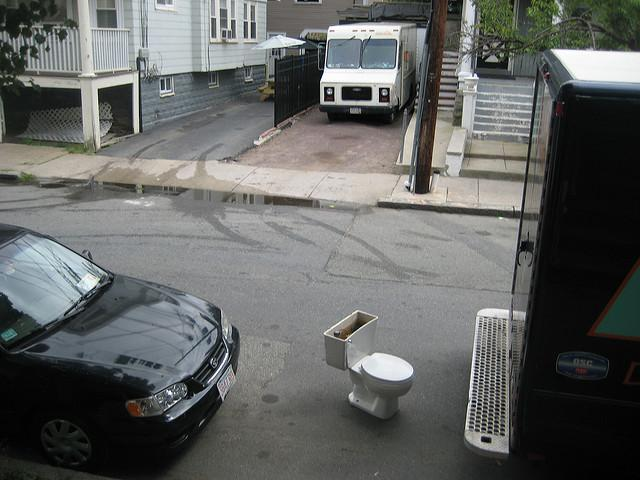What is between the car and the cube truck?

Choices:
A) mirror
B) toilet
C) sink
D) tub toilet 